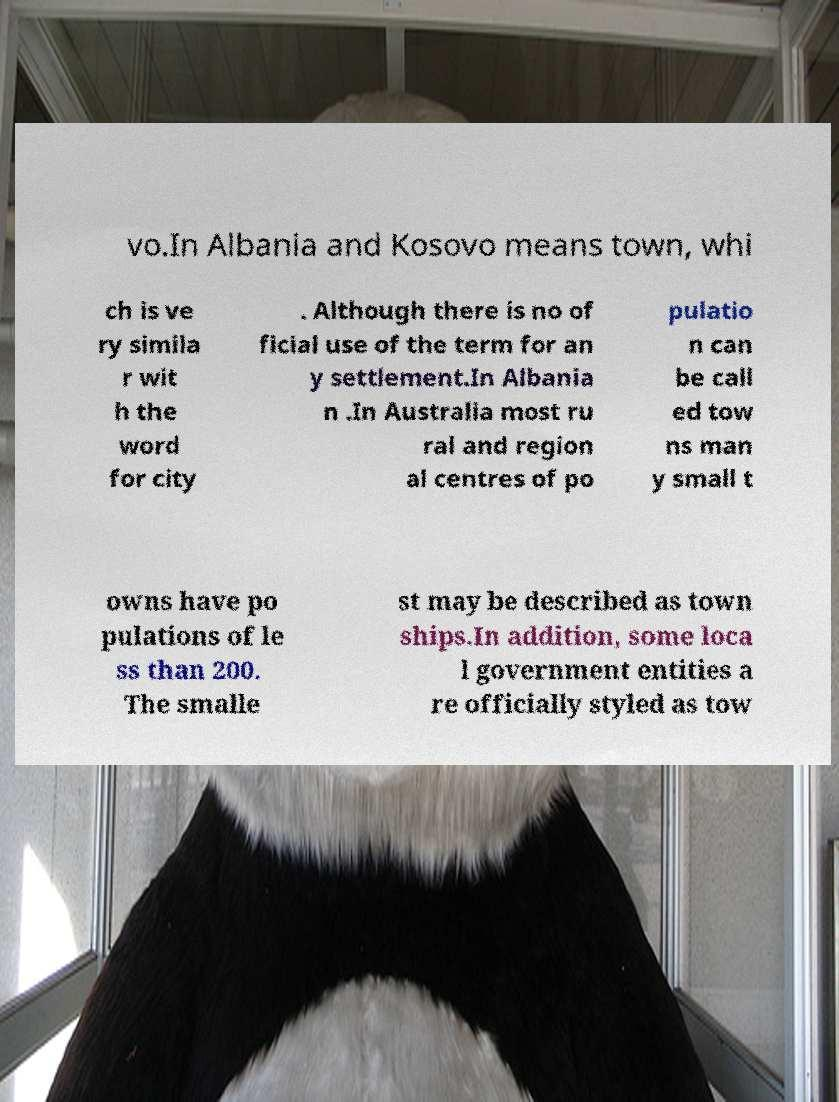Could you extract and type out the text from this image? vo.In Albania and Kosovo means town, whi ch is ve ry simila r wit h the word for city . Although there is no of ficial use of the term for an y settlement.In Albania n .In Australia most ru ral and region al centres of po pulatio n can be call ed tow ns man y small t owns have po pulations of le ss than 200. The smalle st may be described as town ships.In addition, some loca l government entities a re officially styled as tow 